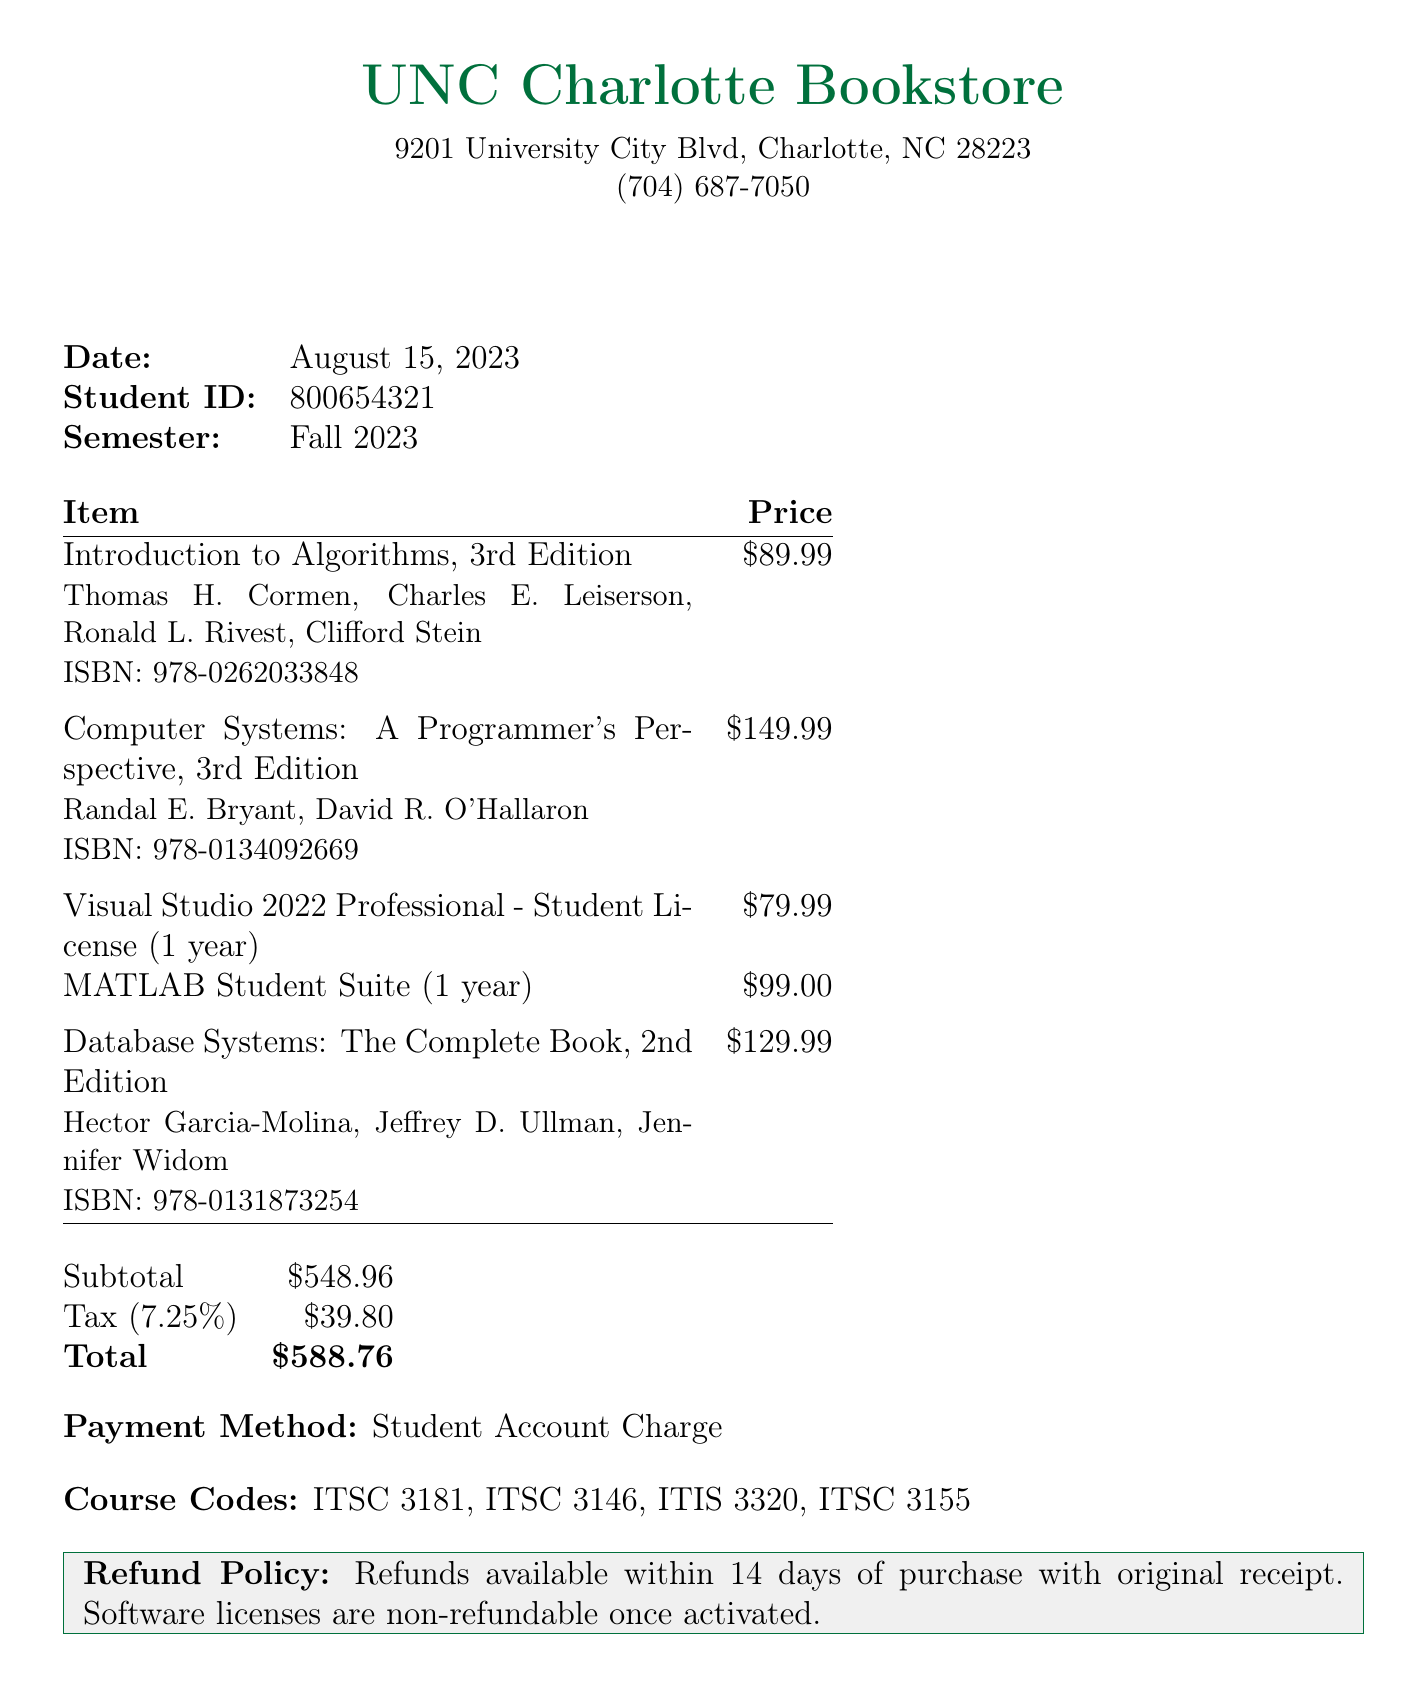What is the store name? The store name is indicated at the top of the document.
Answer: UNC Charlotte Bookstore What is the total amount charged? The total amount is calculated by adding the subtotal and tax amount.
Answer: $588.76 Who is the author of "Introduction to Algorithms, 3rd Edition"? The author of this textbook is listed under the item description.
Answer: Thomas H. Cormen, Charles E. Leiserson, Ronald L. Rivest, Clifford Stein What is the student ID? The student ID is found in the personal details section of the invoice.
Answer: 800654321 What is the refund policy concerning software licenses? The refund policy specifies conditions for returning items, especially software.
Answer: Non-refundable once activated How many textbooks were purchased? The number of textbooks can be counted from the items listed in the document.
Answer: 3 What course codes are associated with this invoice? The course codes are listed in a dedicated section of the document.
Answer: ITSC 3181, ITSC 3146, ITIS 3320, ITSC 3155 What is the date of purchase? The purchase date is prominently displayed in the document header.
Answer: August 15, 2023 What types of items were on the invoice? The document categorizes items into textbooks and software licenses.
Answer: Textbooks and Software 